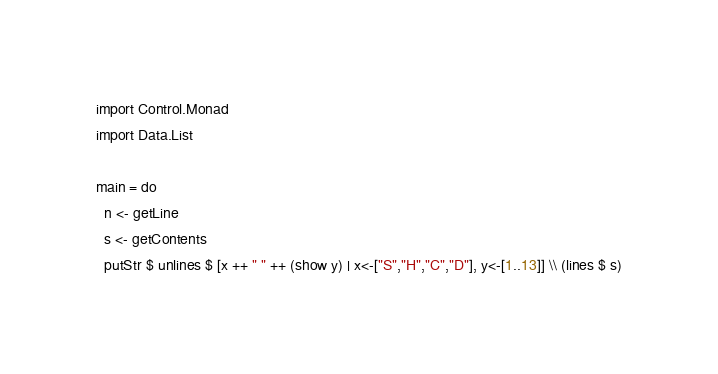Convert code to text. <code><loc_0><loc_0><loc_500><loc_500><_Haskell_>import Control.Monad
import Data.List

main = do
  n <- getLine
  s <- getContents
  putStr $ unlines $ [x ++ " " ++ (show y) | x<-["S","H","C","D"], y<-[1..13]] \\ (lines $ s)</code> 